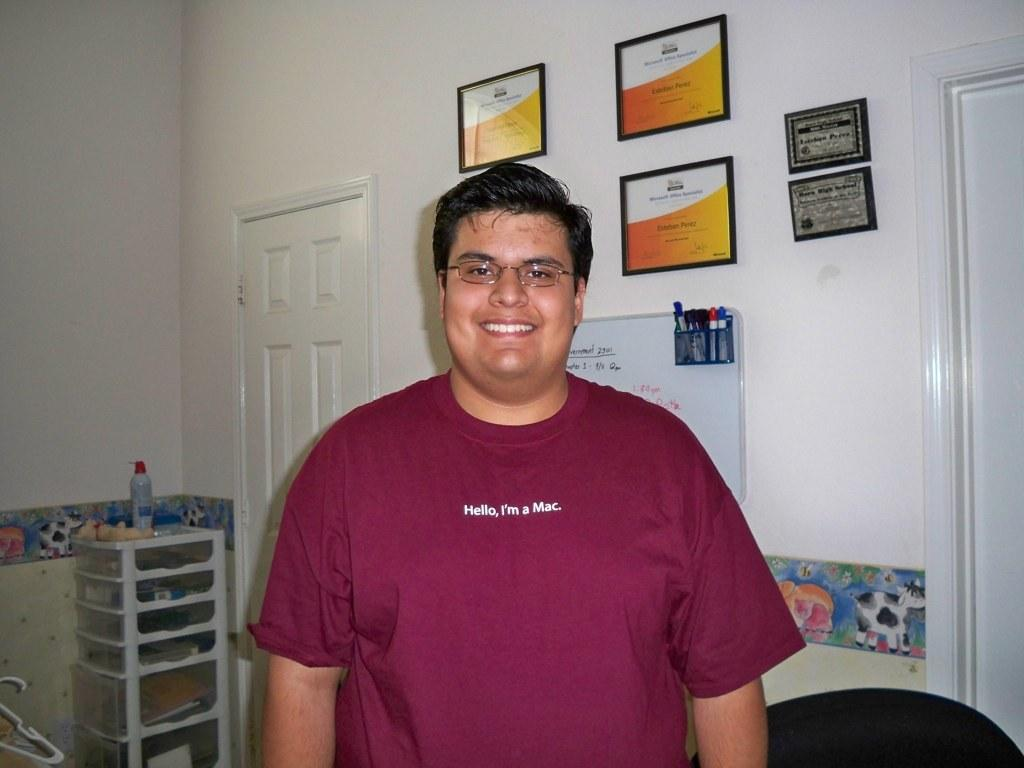Who is present in the image? There is a man in the image. What is the man wearing? The man is wearing spectacles. What is the man's facial expression? The man is smiling. What architectural features can be seen in the image? There are doors visible in the image. What type of decorations are on the wall? There are frames on the wall in the image. What stationery items are present in the image? Sketch pens are present in the image. What surface is available for writing or drawing? There is a board in the image. What type of container is visible in the image? There is a bottle in the image. Can you describe any other objects in the image? There are other objects in the image, but their specific details are not mentioned in the provided facts. How much wealth does the man have, as indicated by the objects in the image? The provided facts do not mention any information about the man's wealth or the value of the objects in the image. 